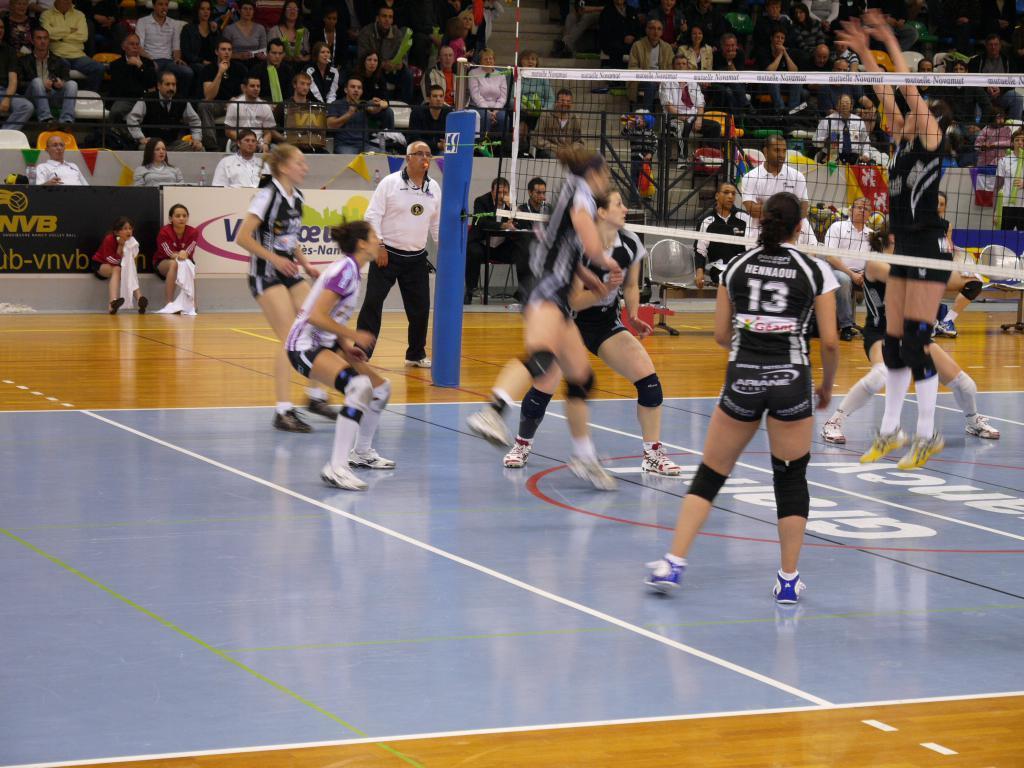Describe this image in one or two sentences. This image is taken in a stadium. In this image there are a few people playing volleyball, in between them there is a net. In the background there are a few spectators. 